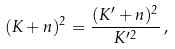<formula> <loc_0><loc_0><loc_500><loc_500>( K + n ) ^ { 2 } = \frac { ( K ^ { \prime } + n ) ^ { 2 } } { K ^ { \prime 2 } } \, ,</formula> 